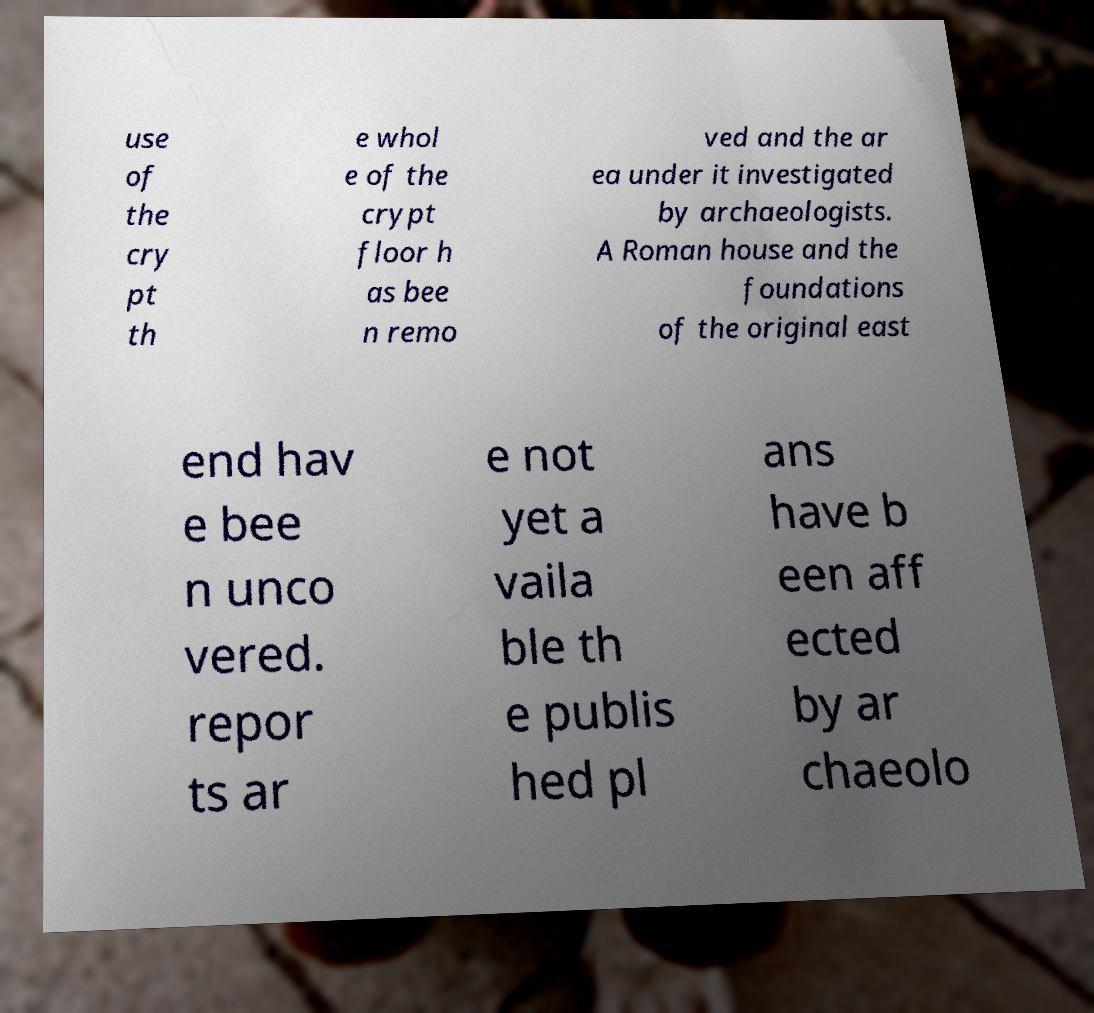Please identify and transcribe the text found in this image. use of the cry pt th e whol e of the crypt floor h as bee n remo ved and the ar ea under it investigated by archaeologists. A Roman house and the foundations of the original east end hav e bee n unco vered. repor ts ar e not yet a vaila ble th e publis hed pl ans have b een aff ected by ar chaeolo 